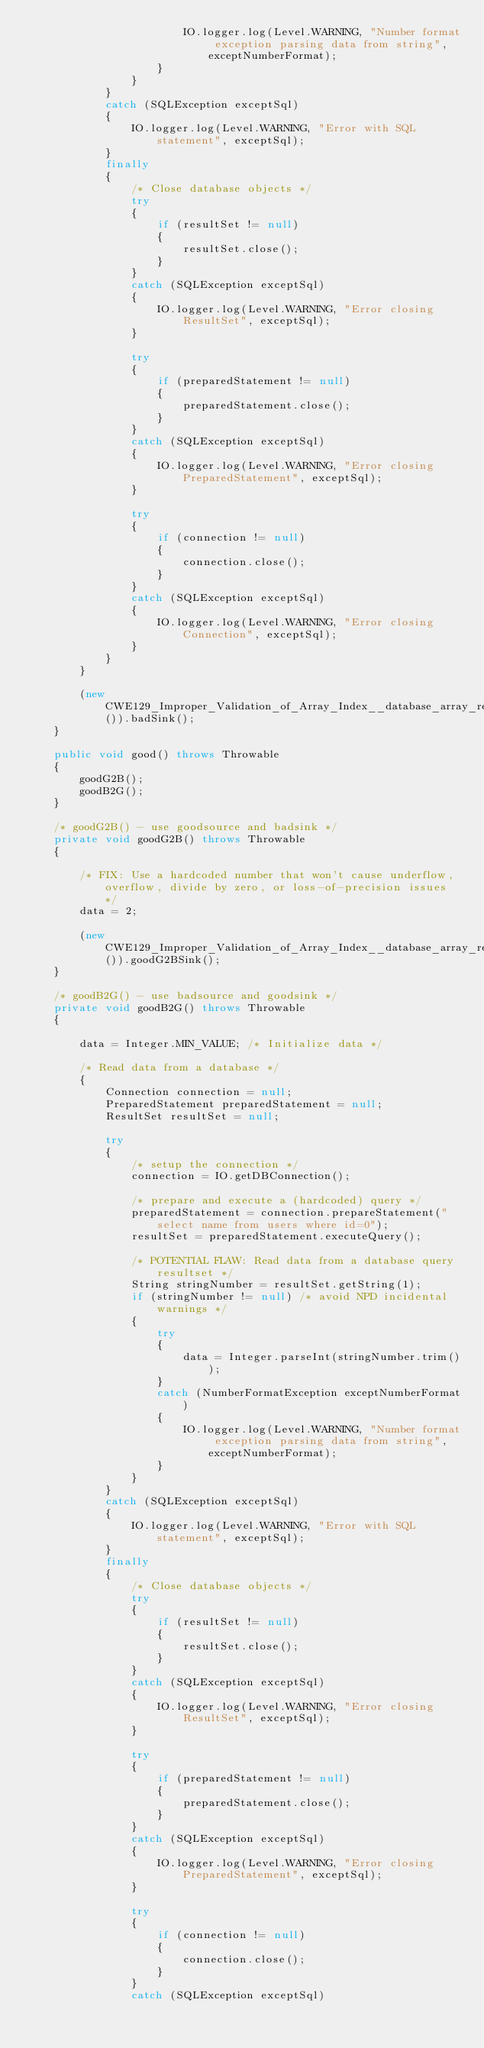Convert code to text. <code><loc_0><loc_0><loc_500><loc_500><_Java_>                        IO.logger.log(Level.WARNING, "Number format exception parsing data from string", exceptNumberFormat);
                    }
                }
            }
            catch (SQLException exceptSql)
            {
                IO.logger.log(Level.WARNING, "Error with SQL statement", exceptSql);
            }
            finally
            {
                /* Close database objects */
                try
                {
                    if (resultSet != null)
                    {
                        resultSet.close();
                    }
                }
                catch (SQLException exceptSql)
                {
                    IO.logger.log(Level.WARNING, "Error closing ResultSet", exceptSql);
                }

                try
                {
                    if (preparedStatement != null)
                    {
                        preparedStatement.close();
                    }
                }
                catch (SQLException exceptSql)
                {
                    IO.logger.log(Level.WARNING, "Error closing PreparedStatement", exceptSql);
                }

                try
                {
                    if (connection != null)
                    {
                        connection.close();
                    }
                }
                catch (SQLException exceptSql)
                {
                    IO.logger.log(Level.WARNING, "Error closing Connection", exceptSql);
                }
            }
        }

        (new CWE129_Improper_Validation_of_Array_Index__database_array_read_check_max_68b()).badSink();
    }

    public void good() throws Throwable
    {
        goodG2B();
        goodB2G();
    }

    /* goodG2B() - use goodsource and badsink */
    private void goodG2B() throws Throwable
    {

        /* FIX: Use a hardcoded number that won't cause underflow, overflow, divide by zero, or loss-of-precision issues */
        data = 2;

        (new CWE129_Improper_Validation_of_Array_Index__database_array_read_check_max_68b()).goodG2BSink();
    }

    /* goodB2G() - use badsource and goodsink */
    private void goodB2G() throws Throwable
    {

        data = Integer.MIN_VALUE; /* Initialize data */

        /* Read data from a database */
        {
            Connection connection = null;
            PreparedStatement preparedStatement = null;
            ResultSet resultSet = null;

            try
            {
                /* setup the connection */
                connection = IO.getDBConnection();

                /* prepare and execute a (hardcoded) query */
                preparedStatement = connection.prepareStatement("select name from users where id=0");
                resultSet = preparedStatement.executeQuery();

                /* POTENTIAL FLAW: Read data from a database query resultset */
                String stringNumber = resultSet.getString(1);
                if (stringNumber != null) /* avoid NPD incidental warnings */
                {
                    try
                    {
                        data = Integer.parseInt(stringNumber.trim());
                    }
                    catch (NumberFormatException exceptNumberFormat)
                    {
                        IO.logger.log(Level.WARNING, "Number format exception parsing data from string", exceptNumberFormat);
                    }
                }
            }
            catch (SQLException exceptSql)
            {
                IO.logger.log(Level.WARNING, "Error with SQL statement", exceptSql);
            }
            finally
            {
                /* Close database objects */
                try
                {
                    if (resultSet != null)
                    {
                        resultSet.close();
                    }
                }
                catch (SQLException exceptSql)
                {
                    IO.logger.log(Level.WARNING, "Error closing ResultSet", exceptSql);
                }

                try
                {
                    if (preparedStatement != null)
                    {
                        preparedStatement.close();
                    }
                }
                catch (SQLException exceptSql)
                {
                    IO.logger.log(Level.WARNING, "Error closing PreparedStatement", exceptSql);
                }

                try
                {
                    if (connection != null)
                    {
                        connection.close();
                    }
                }
                catch (SQLException exceptSql)</code> 